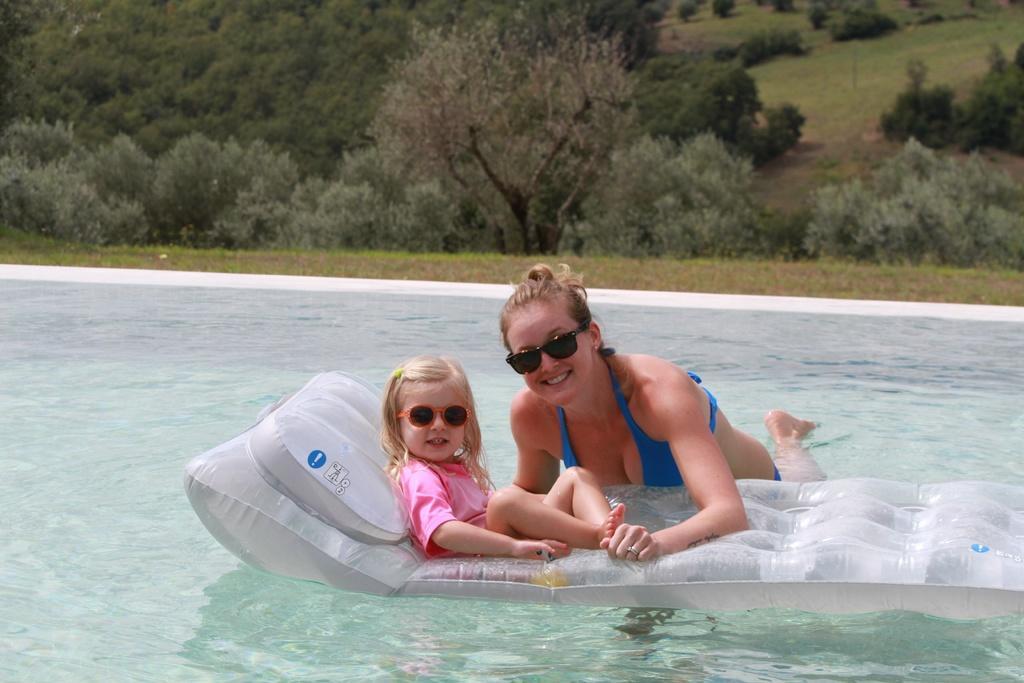How would you summarize this image in a sentence or two? In this picture we can see a girl sitting on a inflatable and a woman in water and they both wore goggles and smiling and in the background we can see trees. 